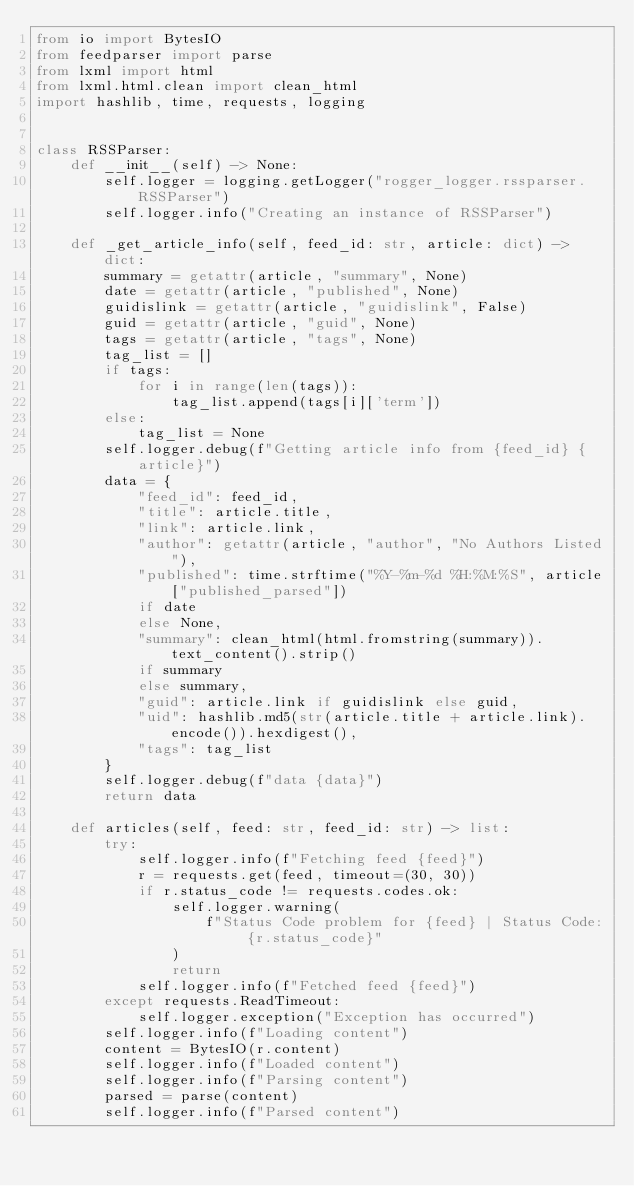Convert code to text. <code><loc_0><loc_0><loc_500><loc_500><_Python_>from io import BytesIO
from feedparser import parse
from lxml import html
from lxml.html.clean import clean_html
import hashlib, time, requests, logging


class RSSParser:
    def __init__(self) -> None:
        self.logger = logging.getLogger("rogger_logger.rssparser.RSSParser")
        self.logger.info("Creating an instance of RSSParser")

    def _get_article_info(self, feed_id: str, article: dict) -> dict:
        summary = getattr(article, "summary", None)
        date = getattr(article, "published", None)
        guidislink = getattr(article, "guidislink", False)
        guid = getattr(article, "guid", None)
        tags = getattr(article, "tags", None)
        tag_list = []
        if tags:
            for i in range(len(tags)):
                tag_list.append(tags[i]['term'])
        else:
            tag_list = None
        self.logger.debug(f"Getting article info from {feed_id} {article}")
        data = {
            "feed_id": feed_id,
            "title": article.title,
            "link": article.link,
            "author": getattr(article, "author", "No Authors Listed"),
            "published": time.strftime("%Y-%m-%d %H:%M:%S", article["published_parsed"])
            if date
            else None,
            "summary": clean_html(html.fromstring(summary)).text_content().strip()
            if summary
            else summary,
            "guid": article.link if guidislink else guid,
            "uid": hashlib.md5(str(article.title + article.link).encode()).hexdigest(),
            "tags": tag_list
        }
        self.logger.debug(f"data {data}")
        return data

    def articles(self, feed: str, feed_id: str) -> list:
        try:
            self.logger.info(f"Fetching feed {feed}")
            r = requests.get(feed, timeout=(30, 30))
            if r.status_code != requests.codes.ok:
                self.logger.warning(
                    f"Status Code problem for {feed} | Status Code: {r.status_code}"
                )
                return
            self.logger.info(f"Fetched feed {feed}")
        except requests.ReadTimeout:
            self.logger.exception("Exception has occurred")
        self.logger.info(f"Loading content")
        content = BytesIO(r.content)
        self.logger.info(f"Loaded content")
        self.logger.info(f"Parsing content")
        parsed = parse(content)
        self.logger.info(f"Parsed content")</code> 